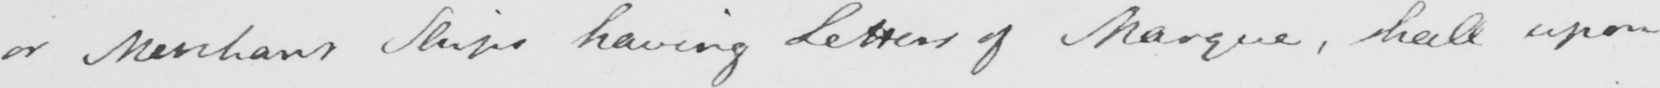Please transcribe the handwritten text in this image. or Merchant Ships having Letters of Marque , shall upon 